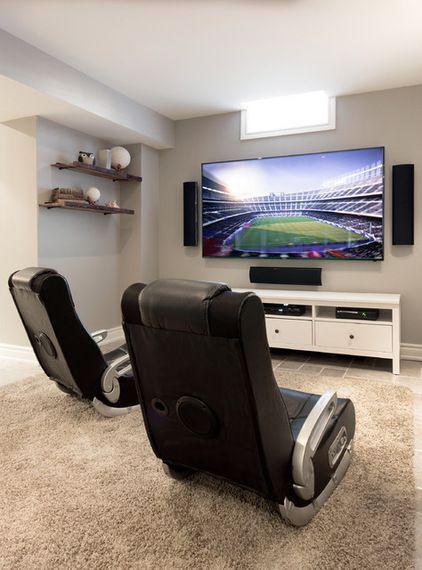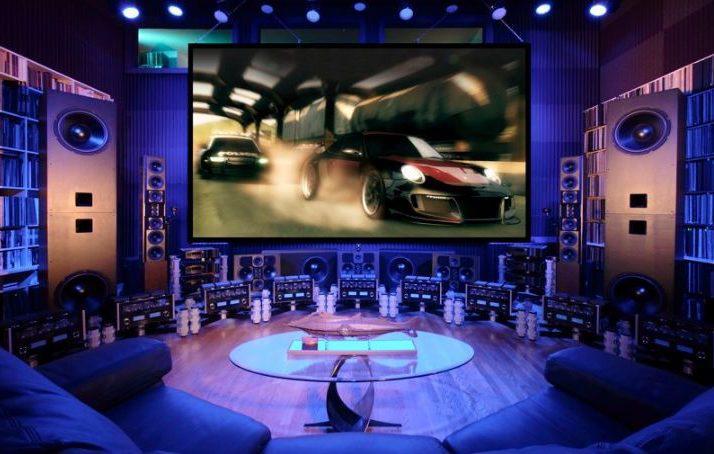The first image is the image on the left, the second image is the image on the right. Examine the images to the left and right. Is the description "Each image shows one wide screen on a wall, with seating in front of it, and one image shows a screen surrounded by a blue glow." accurate? Answer yes or no. Yes. The first image is the image on the left, the second image is the image on the right. Examine the images to the left and right. Is the description "The flat screened TV in front of the sitting area is mounted on the wall." accurate? Answer yes or no. Yes. 